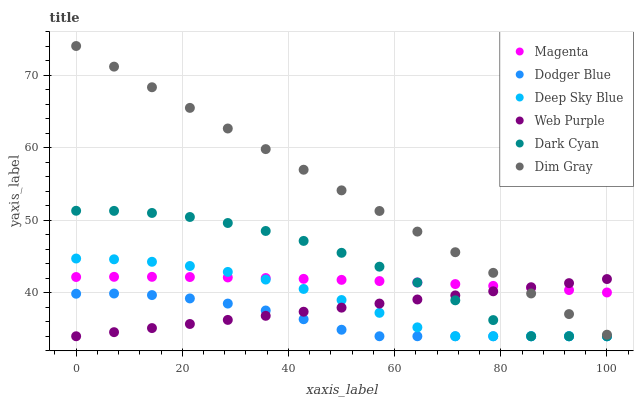Does Dodger Blue have the minimum area under the curve?
Answer yes or no. Yes. Does Dim Gray have the maximum area under the curve?
Answer yes or no. Yes. Does Web Purple have the minimum area under the curve?
Answer yes or no. No. Does Web Purple have the maximum area under the curve?
Answer yes or no. No. Is Web Purple the smoothest?
Answer yes or no. Yes. Is Dark Cyan the roughest?
Answer yes or no. Yes. Is Dodger Blue the smoothest?
Answer yes or no. No. Is Dodger Blue the roughest?
Answer yes or no. No. Does Web Purple have the lowest value?
Answer yes or no. Yes. Does Magenta have the lowest value?
Answer yes or no. No. Does Dim Gray have the highest value?
Answer yes or no. Yes. Does Web Purple have the highest value?
Answer yes or no. No. Is Dodger Blue less than Dim Gray?
Answer yes or no. Yes. Is Magenta greater than Dodger Blue?
Answer yes or no. Yes. Does Deep Sky Blue intersect Web Purple?
Answer yes or no. Yes. Is Deep Sky Blue less than Web Purple?
Answer yes or no. No. Is Deep Sky Blue greater than Web Purple?
Answer yes or no. No. Does Dodger Blue intersect Dim Gray?
Answer yes or no. No. 